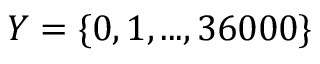Convert formula to latex. <formula><loc_0><loc_0><loc_500><loc_500>Y = \{ 0 , 1 , \dots , 3 6 0 0 0 \}</formula> 